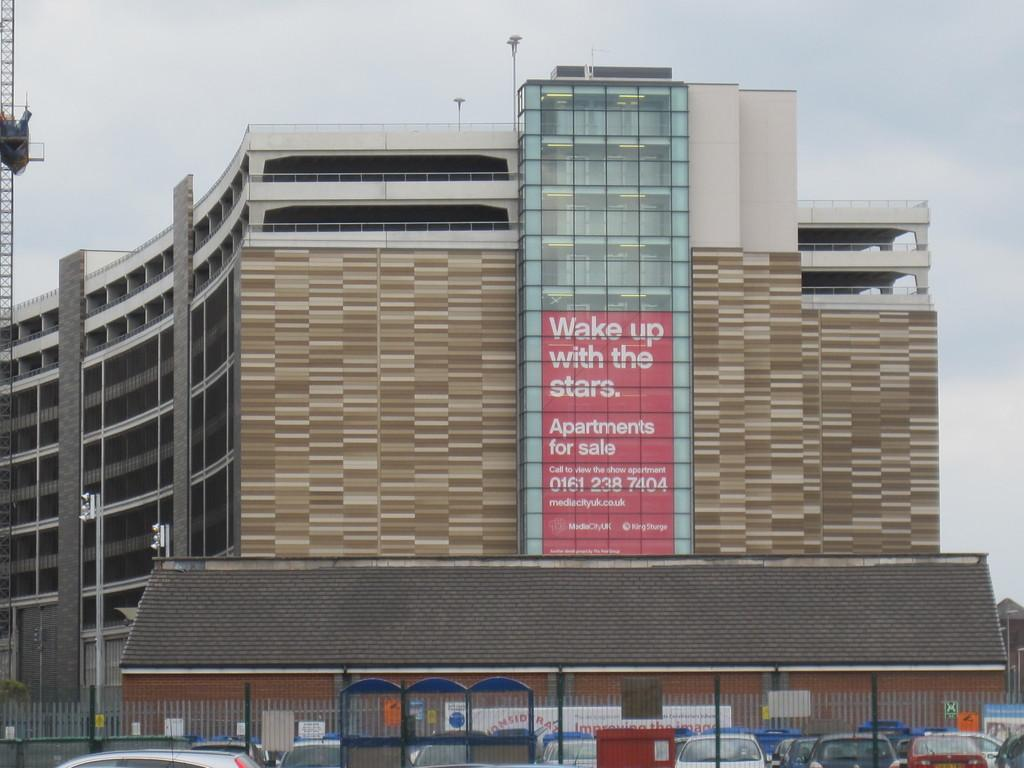What type of vehicles are in the front of the image? There are cars in the front of the image. What is separating the cars from the background? There is a fence in the image. What can be seen in the distance behind the fence? There is a building in the background of the image. What is written on the building? There is text written on the building. What is the weather like in the image? The sky is cloudy in the image. How many sisters are playing in the image? There are no sisters present in the image. What does the mom say about the show in the image? There is no mom or show present in the image. 